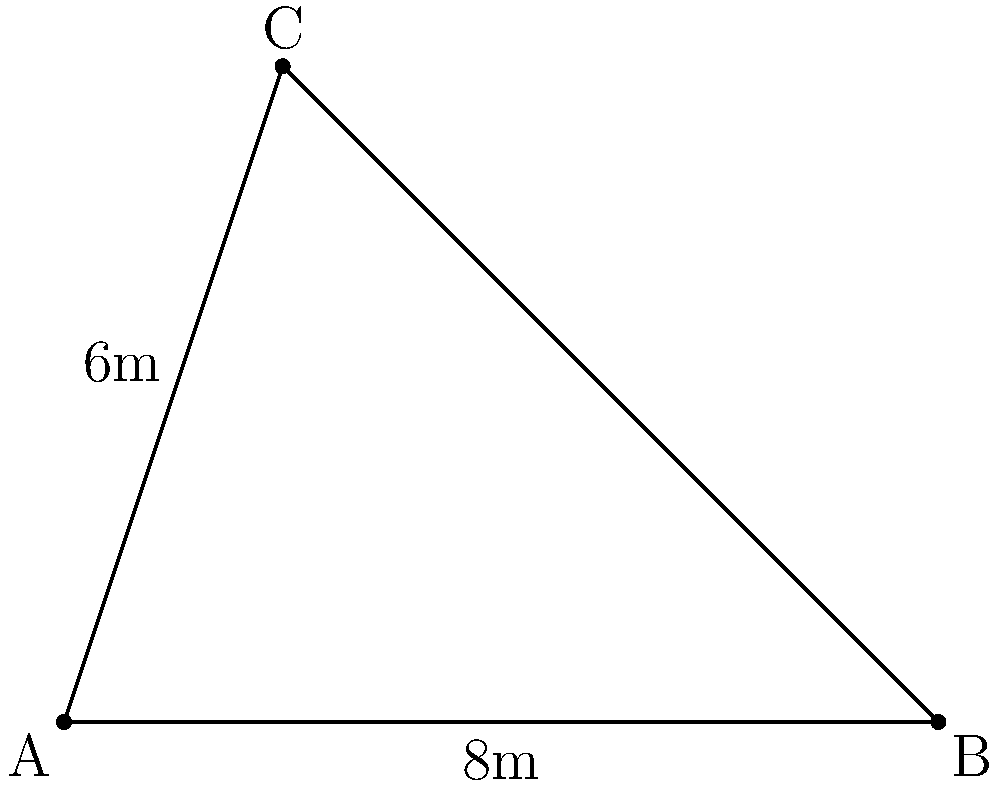During a Naomh Fionnbarra GAA Club training session, player A is positioned at one corner of the pitch, player B is 8 meters directly in front of A, and player C is 6 meters away from A at a right angle to line AB. What is the shortest distance between players B and C? To solve this problem, we can use the Pythagorean theorem:

1. Identify the right-angled triangle: ABC is a right-angled triangle with the right angle at A.

2. We know two sides of this triangle:
   - AB = 8 meters
   - AC = 6 meters

3. We need to find BC, which is the hypotenuse of this right-angled triangle.

4. Apply the Pythagorean theorem: $a^2 + b^2 = c^2$
   Where $c$ is the hypotenuse (BC) and $a$ and $b$ are the other two sides (AB and AC).

5. Substitute the known values:
   $8^2 + 6^2 = BC^2$

6. Calculate:
   $64 + 36 = BC^2$
   $100 = BC^2$

7. Take the square root of both sides:
   $\sqrt{100} = BC$
   $10 = BC$

Therefore, the shortest distance between players B and C is 10 meters.
Answer: 10 meters 